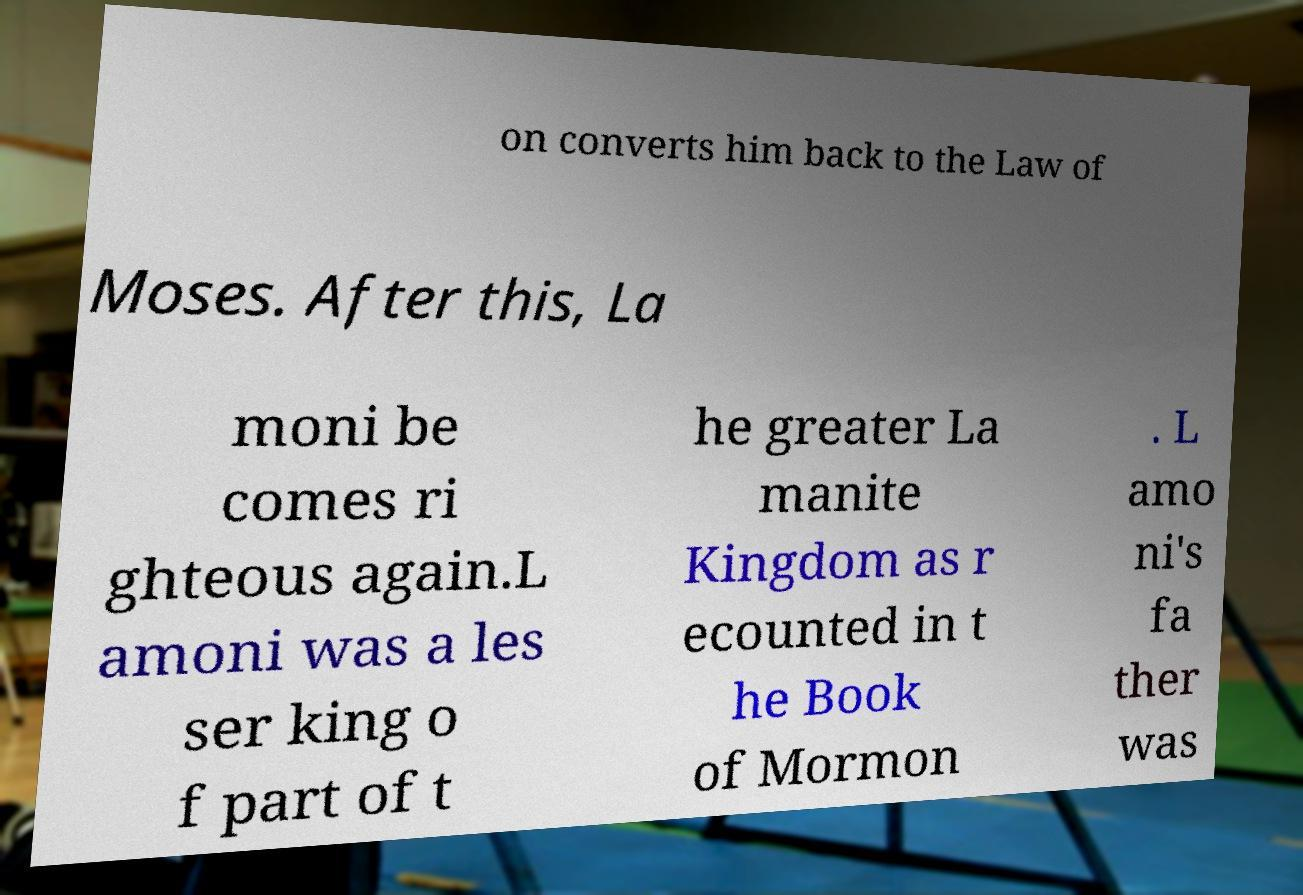Could you assist in decoding the text presented in this image and type it out clearly? on converts him back to the Law of Moses. After this, La moni be comes ri ghteous again.L amoni was a les ser king o f part of t he greater La manite Kingdom as r ecounted in t he Book of Mormon . L amo ni's fa ther was 